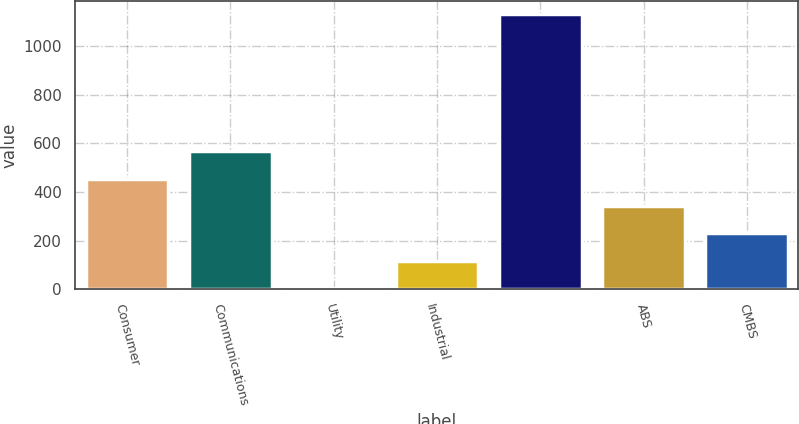Convert chart to OTSL. <chart><loc_0><loc_0><loc_500><loc_500><bar_chart><fcel>Consumer<fcel>Communications<fcel>Utility<fcel>Industrial<fcel>Unnamed: 4<fcel>ABS<fcel>CMBS<nl><fcel>455<fcel>567.5<fcel>5<fcel>117.5<fcel>1130<fcel>342.5<fcel>230<nl></chart> 